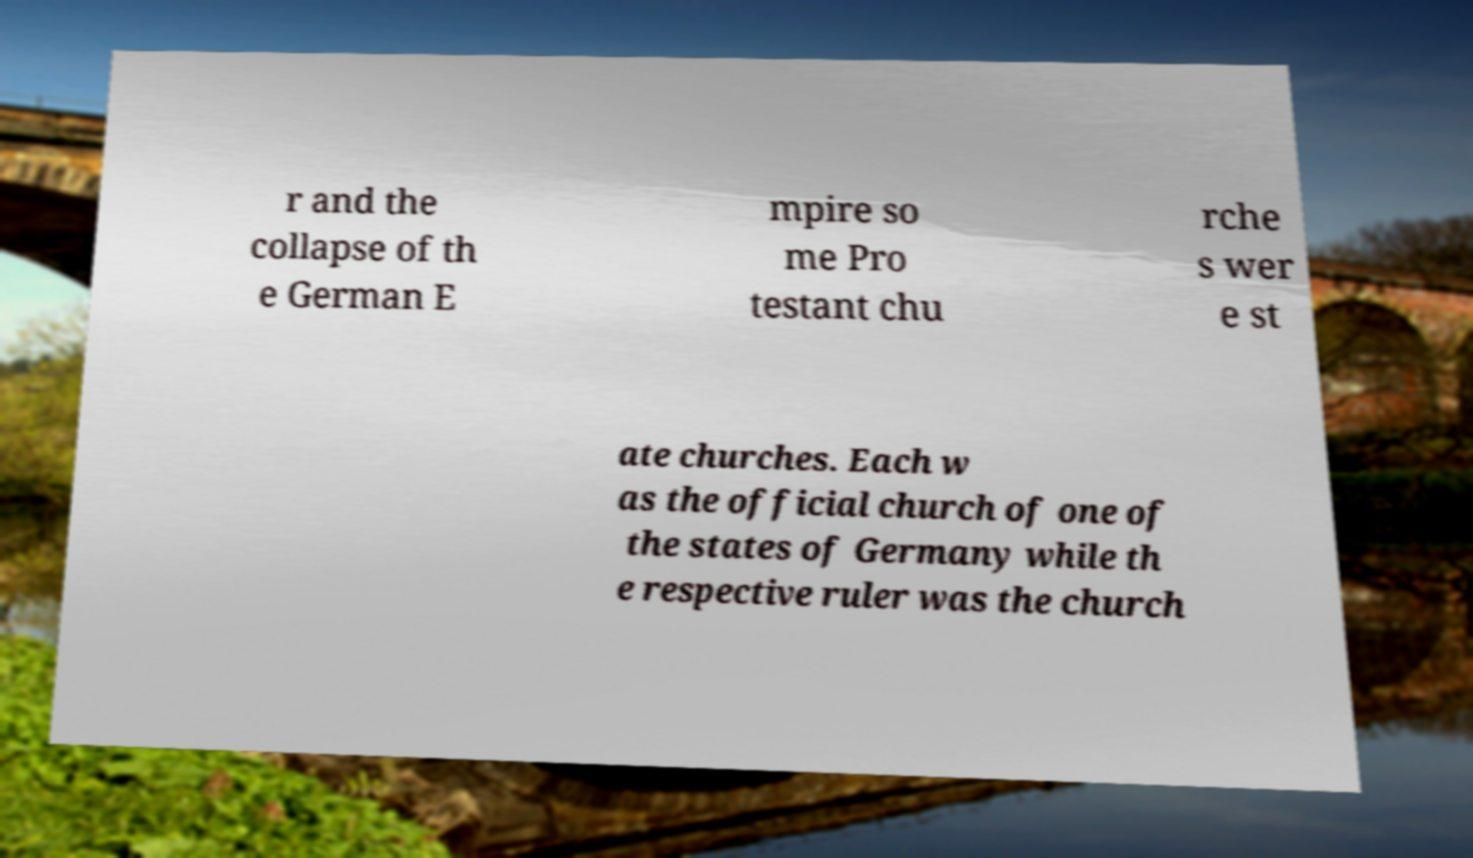What messages or text are displayed in this image? I need them in a readable, typed format. r and the collapse of th e German E mpire so me Pro testant chu rche s wer e st ate churches. Each w as the official church of one of the states of Germany while th e respective ruler was the church 